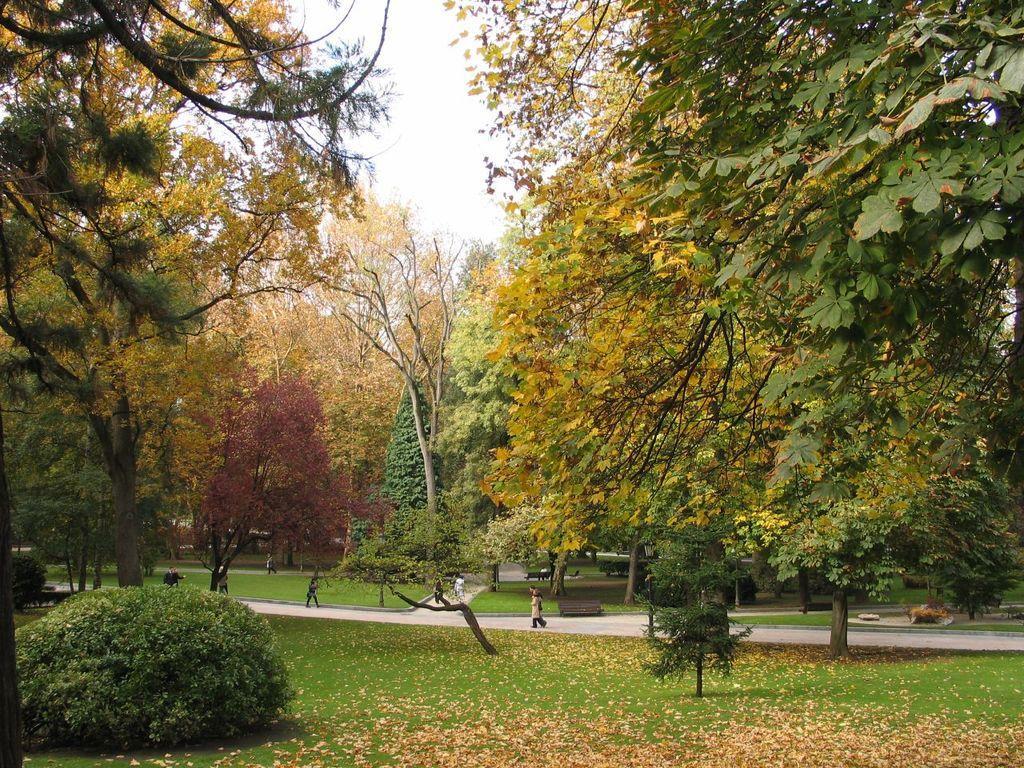Could you give a brief overview of what you see in this image? This picture is clicked outside. In the foreground we can see the green grass, plants, trees and the dry leaves lying on the ground. In the center we can see the group of people seems to be walking on the ground and we can see the benches, green grass, plants, trees and some other objects. In the background we can see the sky. 